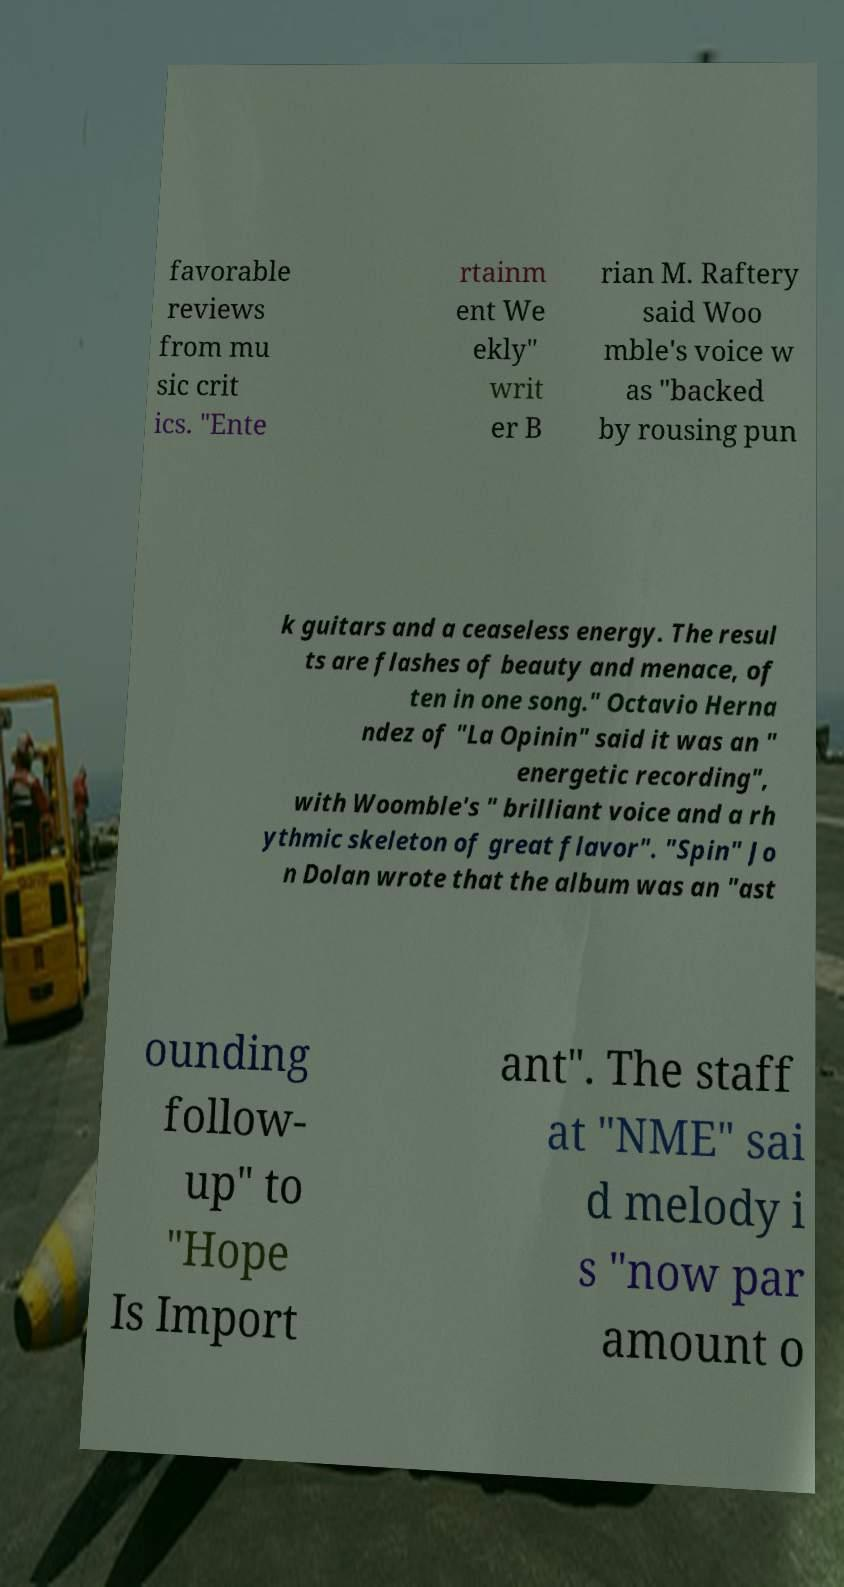There's text embedded in this image that I need extracted. Can you transcribe it verbatim? favorable reviews from mu sic crit ics. "Ente rtainm ent We ekly" writ er B rian M. Raftery said Woo mble's voice w as "backed by rousing pun k guitars and a ceaseless energy. The resul ts are flashes of beauty and menace, of ten in one song." Octavio Herna ndez of "La Opinin" said it was an " energetic recording", with Woomble's " brilliant voice and a rh ythmic skeleton of great flavor". "Spin" Jo n Dolan wrote that the album was an "ast ounding follow- up" to "Hope Is Import ant". The staff at "NME" sai d melody i s "now par amount o 